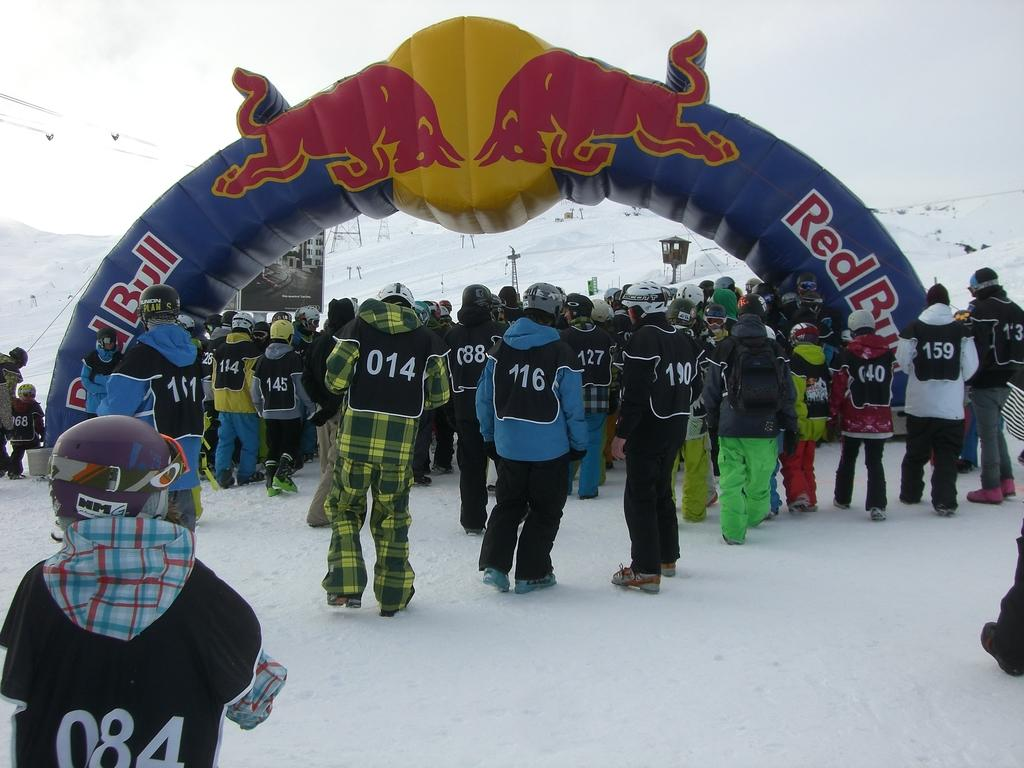What is the main subject of the image? There is a group of people on the ground. What can be seen in the background of the image? In the background, there is an inflatable arch, a poster, poles, snow, and some unspecified objects. Can you describe the inflatable arch in the background? The inflatable arch is a large, inflated structure that is likely used for an event or race. What type of weather is suggested by the presence of snow in the background? The presence of snow in the background suggests that the weather is cold and possibly wintry. Reasoning: Let's think step by step by step in order to produce the conversation. We start by identifying the main subject of the image, which is the group of people on the ground. Then, we describe the various elements in the background, including the inflatable arch, poster, poles, snow, and unspecified objects. We provide additional details about the inflatable arch to give a better understanding of its purpose. Finally, we use the presence of snow to infer the weather conditions in the image. Absurd Question/Answer: How many letters are visible on the rail in the image? There is no rail present in the image, and therefore no letters can be observed on it. Can you describe the type of bike that is leaning against the poster in the image? There is no bike present in the image, and therefore no such object can be described. 